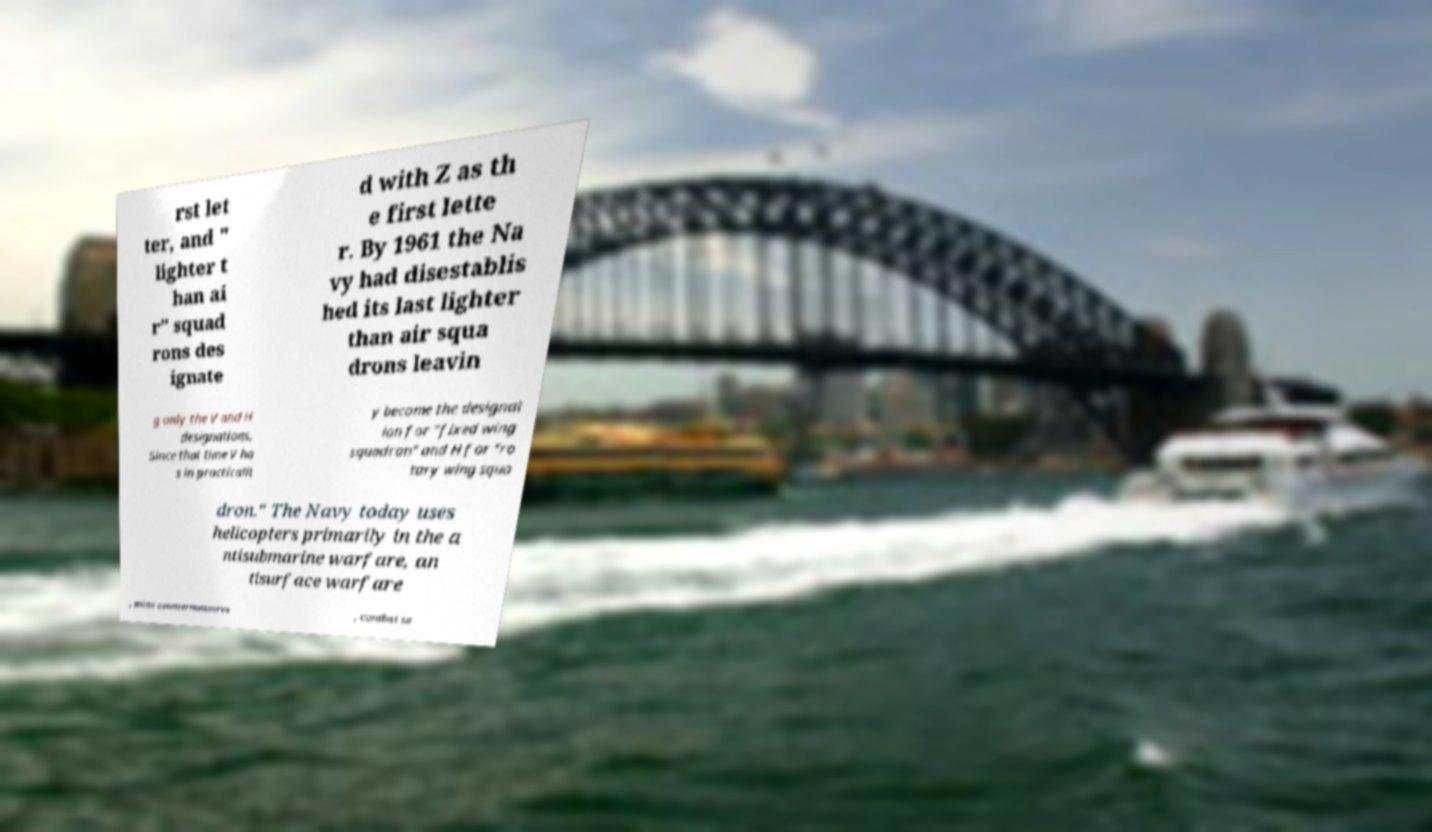What messages or text are displayed in this image? I need them in a readable, typed format. rst let ter, and " lighter t han ai r" squad rons des ignate d with Z as th e first lette r. By 1961 the Na vy had disestablis hed its last lighter than air squa drons leavin g only the V and H designations. Since that time V ha s in practicalit y become the designat ion for "fixed wing squadron" and H for "ro tary wing squa dron." The Navy today uses helicopters primarily in the a ntisubmarine warfare, an tisurface warfare , mine countermeasures , combat se 